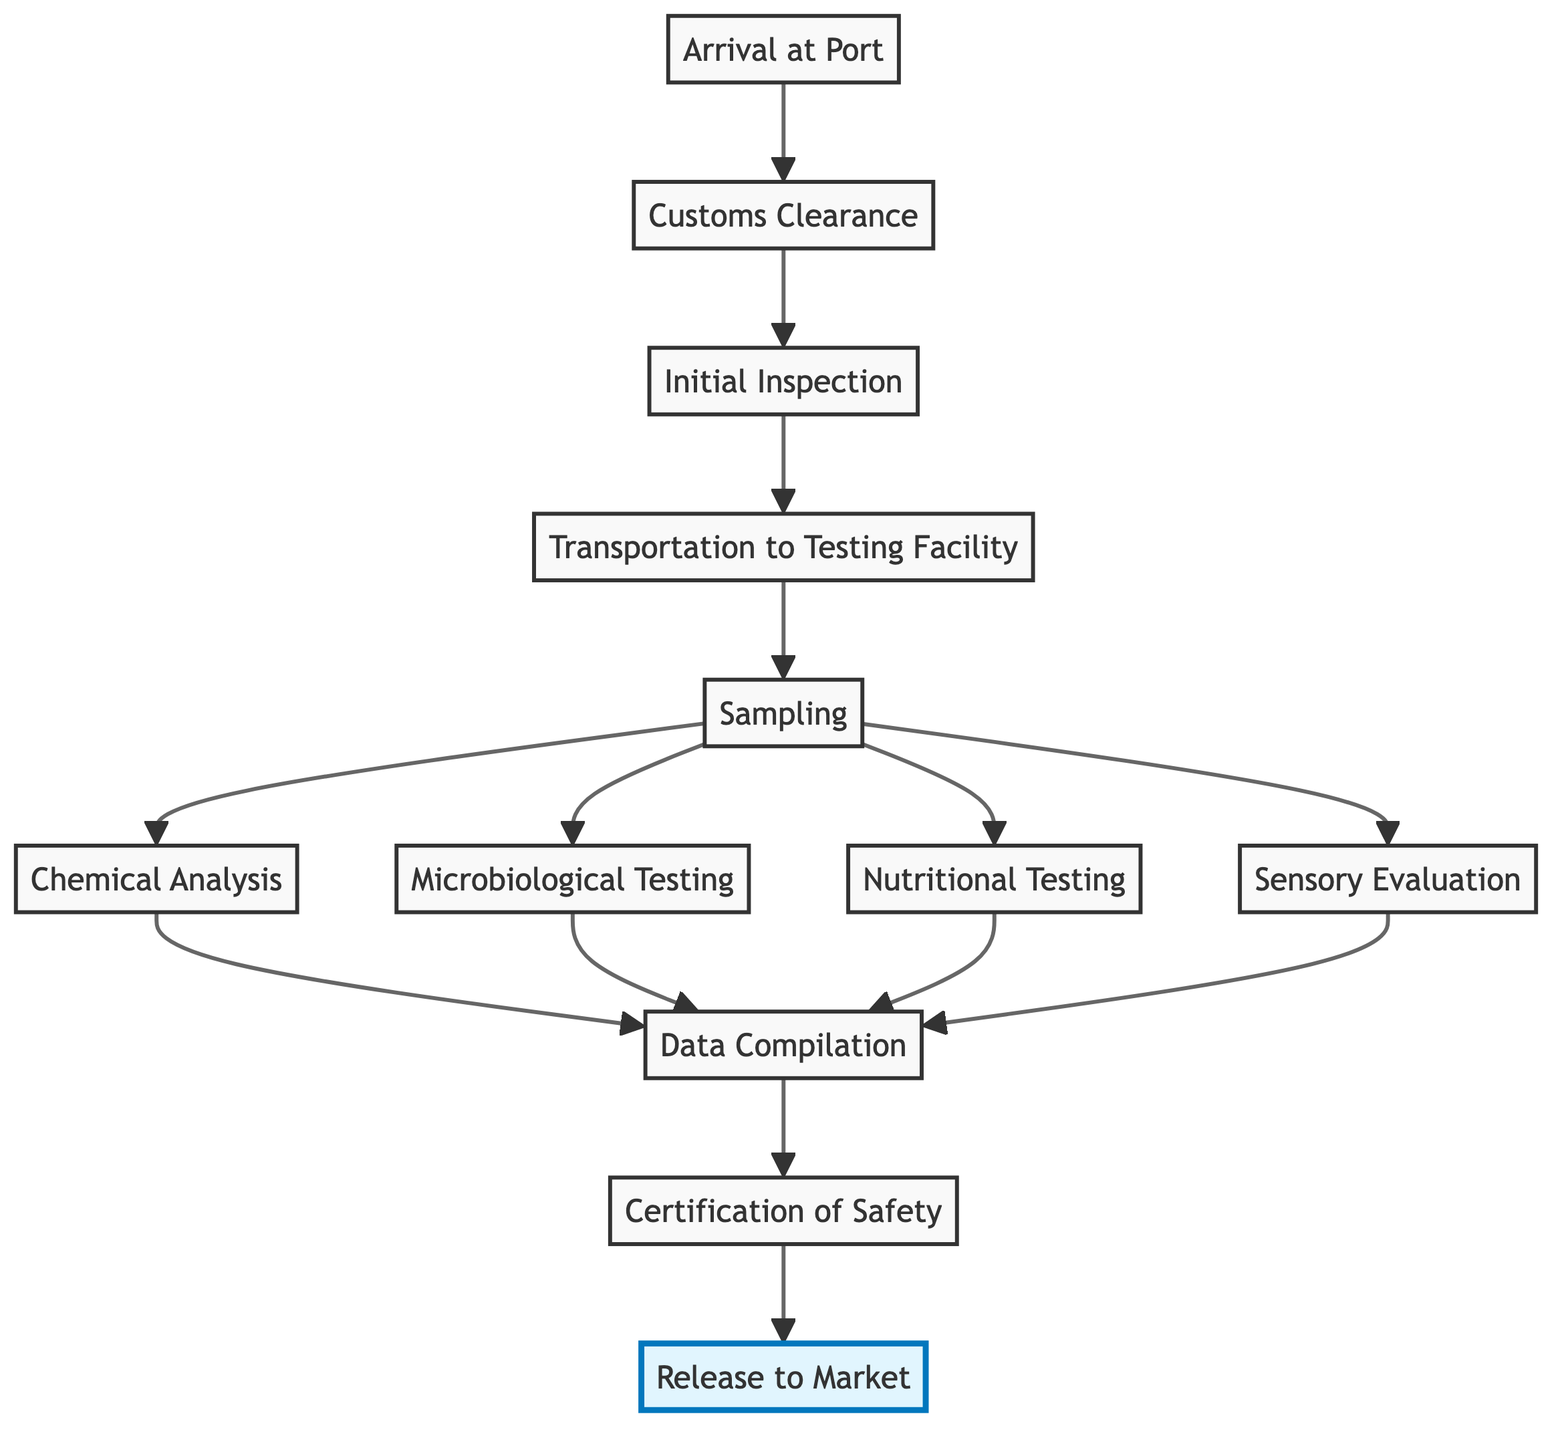What is the first step in the process? The first step listed in the diagram is "Arrival at Port," showing the beginning of the ingredient testing process when the ingredients are received.
Answer: Arrival at Port How many testing types are involved before data compilation? The diagram indicates there are four types of testing: Chemical Analysis, Microbiological Testing, Nutritional Testing, and Sensory Evaluation, all of which occur after sampling.
Answer: 4 What happens after "Data Compilation"? Following "Data Compilation," the next step is "Certification of Safety," indicating that the results are evaluated to determine if the ingredients can be certified as safe for use.
Answer: Certification of Safety What is the last step in the import ingredient testing process? The final step in the flowchart is "Release to Market," which shows that ingredients compliant with safety standards are allowed for use in fusion recipes.
Answer: Release to Market What must occur before transportation to the testing facility? Before transportation can occur, "Initial Inspection" must take place, ensuring the ingredients are free of visible defects or contaminations.
Answer: Initial Inspection What step involves checking for pathogens? "Microbiological Testing" is the step dedicated to assessing ingredients for harmful pathogens such as Salmonella and E. coli.
Answer: Microbiological Testing What process follows "Sampling"? After "Sampling," the next steps that take place are "Chemical Analysis," "Microbiological Testing," "Nutritional Testing," and "Sensory Evaluation."
Answer: Chemical Analysis, Microbiological Testing, Nutritional Testing, Sensory Evaluation How do ingredients get certified as safe? Ingredients are certified as safe after comprehensive testing results are compiled and validated at the "Certification of Safety" step, ensuring compliance with regulatory standards.
Answer: Certification of Safety 